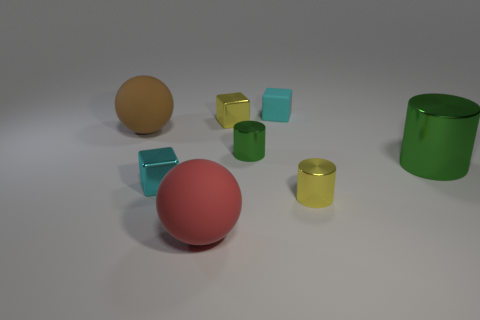What color is the big metal thing?
Offer a terse response. Green. There is a object that is the same color as the big cylinder; what shape is it?
Provide a succinct answer. Cylinder. The rubber cube that is the same size as the yellow shiny cylinder is what color?
Your response must be concise. Cyan. How many shiny things are small purple cubes or big green objects?
Make the answer very short. 1. What number of rubber things are right of the brown rubber thing and to the left of the cyan rubber object?
Give a very brief answer. 1. What number of other things are the same size as the matte block?
Provide a succinct answer. 4. Do the cyan block in front of the large green object and the green metal object that is right of the yellow cylinder have the same size?
Provide a succinct answer. No. How many things are large brown objects or objects behind the big red matte thing?
Give a very brief answer. 7. How big is the metallic block on the left side of the red rubber object?
Provide a short and direct response. Small. Are there fewer red balls left of the tiny matte object than cyan rubber cubes that are left of the red rubber sphere?
Keep it short and to the point. No. 